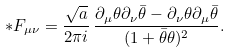<formula> <loc_0><loc_0><loc_500><loc_500>{ * } F _ { \mu \nu } = \frac { \sqrt { a } } { 2 \pi i } \, \frac { \partial _ { \mu } \theta \partial _ { \nu } { \bar { \theta } } - \partial _ { \nu } \theta \partial _ { \mu } { \bar { \theta } } } { ( 1 + { \bar { \theta } } \theta ) ^ { 2 } } .</formula> 